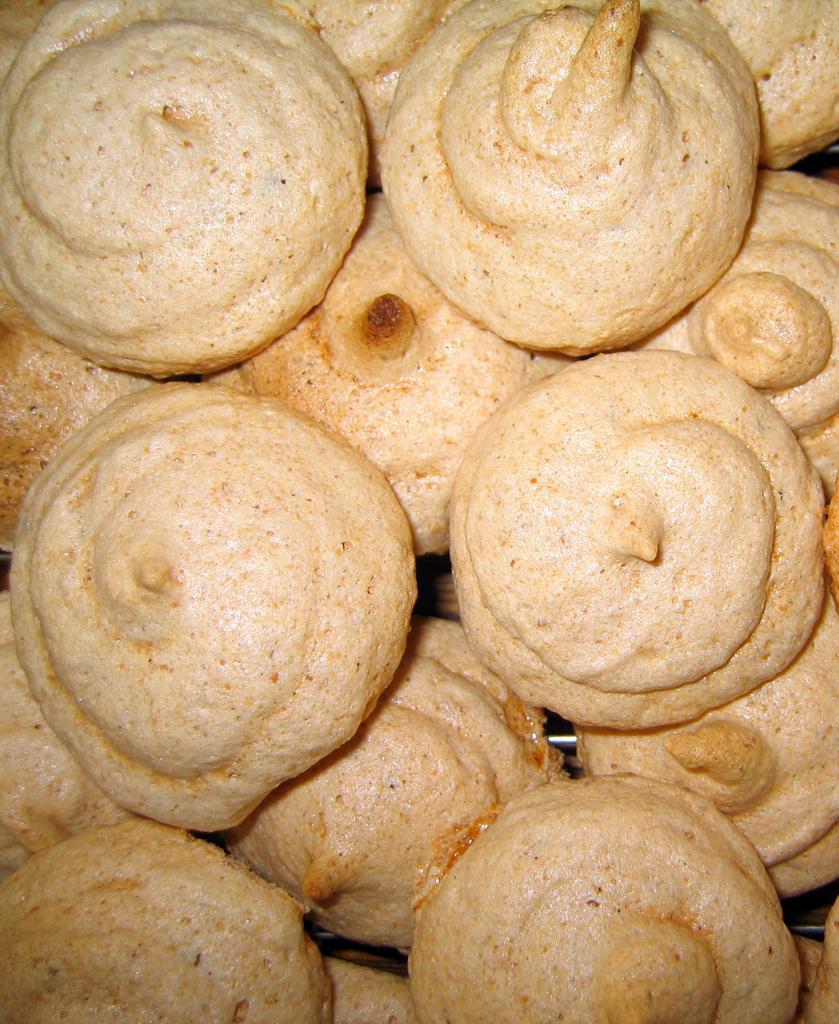In one or two sentences, can you explain what this image depicts? In this image we can see food items on an object. 